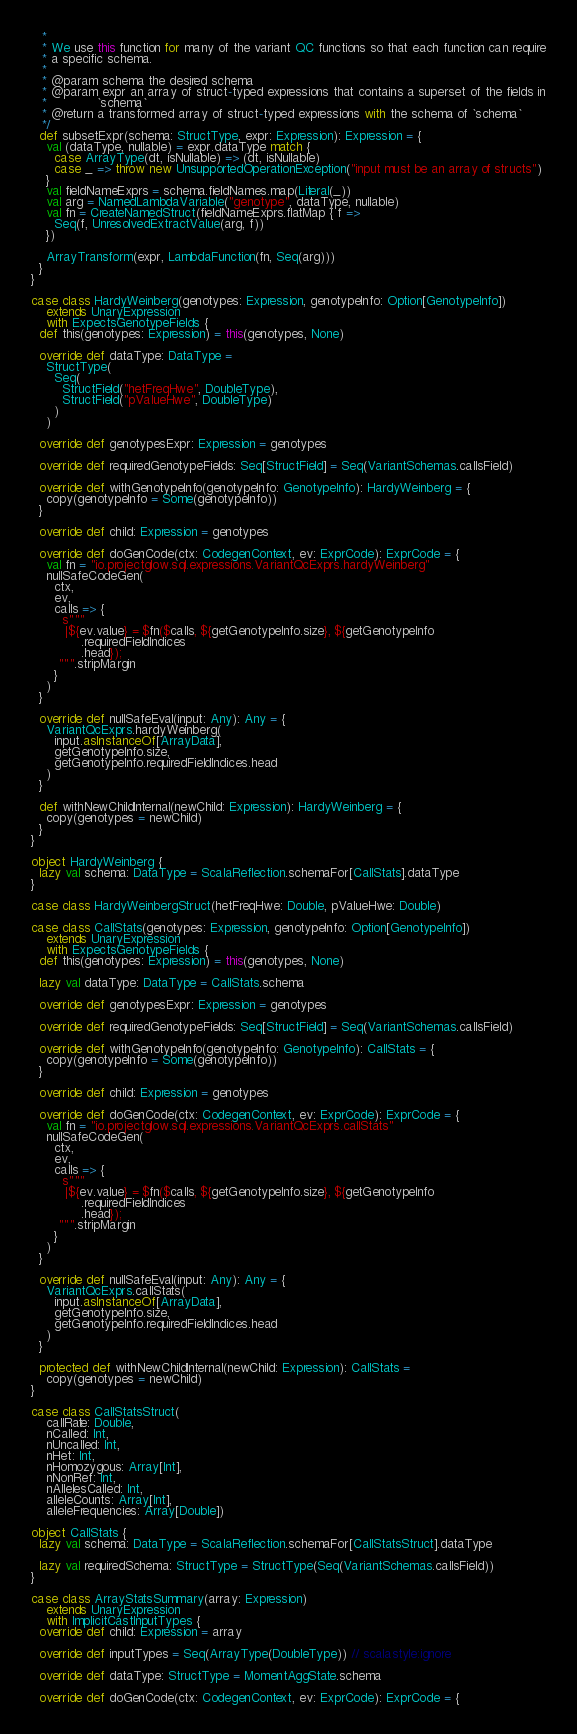Convert code to text. <code><loc_0><loc_0><loc_500><loc_500><_Scala_>   *
   * We use this function for many of the variant QC functions so that each function can require
   * a specific schema.
   *
   * @param schema the desired schema
   * @param expr an array of struct-typed expressions that contains a superset of the fields in
   *             `schema`
   * @return a transformed array of struct-typed expressions with the schema of `schema`
   */
  def subsetExpr(schema: StructType, expr: Expression): Expression = {
    val (dataType, nullable) = expr.dataType match {
      case ArrayType(dt, isNullable) => (dt, isNullable)
      case _ => throw new UnsupportedOperationException("input must be an array of structs")
    }
    val fieldNameExprs = schema.fieldNames.map(Literal(_))
    val arg = NamedLambdaVariable("genotype", dataType, nullable)
    val fn = CreateNamedStruct(fieldNameExprs.flatMap { f =>
      Seq(f, UnresolvedExtractValue(arg, f))
    })

    ArrayTransform(expr, LambdaFunction(fn, Seq(arg)))
  }
}

case class HardyWeinberg(genotypes: Expression, genotypeInfo: Option[GenotypeInfo])
    extends UnaryExpression
    with ExpectsGenotypeFields {
  def this(genotypes: Expression) = this(genotypes, None)

  override def dataType: DataType =
    StructType(
      Seq(
        StructField("hetFreqHwe", DoubleType),
        StructField("pValueHwe", DoubleType)
      )
    )

  override def genotypesExpr: Expression = genotypes

  override def requiredGenotypeFields: Seq[StructField] = Seq(VariantSchemas.callsField)

  override def withGenotypeInfo(genotypeInfo: GenotypeInfo): HardyWeinberg = {
    copy(genotypeInfo = Some(genotypeInfo))
  }

  override def child: Expression = genotypes

  override def doGenCode(ctx: CodegenContext, ev: ExprCode): ExprCode = {
    val fn = "io.projectglow.sql.expressions.VariantQcExprs.hardyWeinberg"
    nullSafeCodeGen(
      ctx,
      ev,
      calls => {
        s"""
         |${ev.value} = $fn($calls, ${getGenotypeInfo.size}, ${getGenotypeInfo
             .requiredFieldIndices
             .head});
       """.stripMargin
      }
    )
  }

  override def nullSafeEval(input: Any): Any = {
    VariantQcExprs.hardyWeinberg(
      input.asInstanceOf[ArrayData],
      getGenotypeInfo.size,
      getGenotypeInfo.requiredFieldIndices.head
    )
  }

  def withNewChildInternal(newChild: Expression): HardyWeinberg = {
    copy(genotypes = newChild)
  }
}

object HardyWeinberg {
  lazy val schema: DataType = ScalaReflection.schemaFor[CallStats].dataType
}

case class HardyWeinbergStruct(hetFreqHwe: Double, pValueHwe: Double)

case class CallStats(genotypes: Expression, genotypeInfo: Option[GenotypeInfo])
    extends UnaryExpression
    with ExpectsGenotypeFields {
  def this(genotypes: Expression) = this(genotypes, None)

  lazy val dataType: DataType = CallStats.schema

  override def genotypesExpr: Expression = genotypes

  override def requiredGenotypeFields: Seq[StructField] = Seq(VariantSchemas.callsField)

  override def withGenotypeInfo(genotypeInfo: GenotypeInfo): CallStats = {
    copy(genotypeInfo = Some(genotypeInfo))
  }

  override def child: Expression = genotypes

  override def doGenCode(ctx: CodegenContext, ev: ExprCode): ExprCode = {
    val fn = "io.projectglow.sql.expressions.VariantQcExprs.callStats"
    nullSafeCodeGen(
      ctx,
      ev,
      calls => {
        s"""
         |${ev.value} = $fn($calls, ${getGenotypeInfo.size}, ${getGenotypeInfo
             .requiredFieldIndices
             .head});
       """.stripMargin
      }
    )
  }

  override def nullSafeEval(input: Any): Any = {
    VariantQcExprs.callStats(
      input.asInstanceOf[ArrayData],
      getGenotypeInfo.size,
      getGenotypeInfo.requiredFieldIndices.head
    )
  }

  protected def withNewChildInternal(newChild: Expression): CallStats =
    copy(genotypes = newChild)
}

case class CallStatsStruct(
    callRate: Double,
    nCalled: Int,
    nUncalled: Int,
    nHet: Int,
    nHomozygous: Array[Int],
    nNonRef: Int,
    nAllelesCalled: Int,
    alleleCounts: Array[Int],
    alleleFrequencies: Array[Double])

object CallStats {
  lazy val schema: DataType = ScalaReflection.schemaFor[CallStatsStruct].dataType

  lazy val requiredSchema: StructType = StructType(Seq(VariantSchemas.callsField))
}

case class ArrayStatsSummary(array: Expression)
    extends UnaryExpression
    with ImplicitCastInputTypes {
  override def child: Expression = array

  override def inputTypes = Seq(ArrayType(DoubleType)) // scalastyle:ignore

  override def dataType: StructType = MomentAggState.schema

  override def doGenCode(ctx: CodegenContext, ev: ExprCode): ExprCode = {</code> 